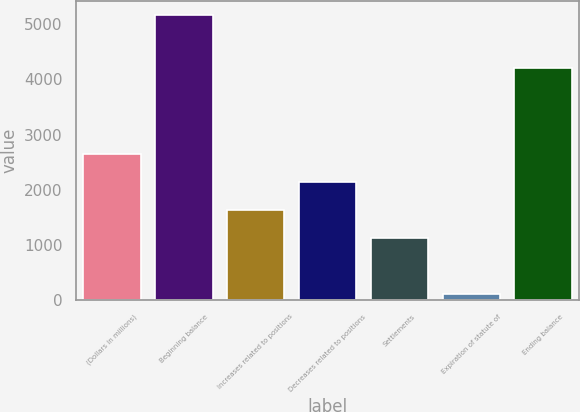Convert chart. <chart><loc_0><loc_0><loc_500><loc_500><bar_chart><fcel>(Dollars in millions)<fcel>Beginning balance<fcel>Increases related to positions<fcel>Decreases related to positions<fcel>Settlements<fcel>Expiration of statute of<fcel>Ending balance<nl><fcel>2643.5<fcel>5169<fcel>1633.3<fcel>2138.4<fcel>1128.2<fcel>118<fcel>4203<nl></chart> 